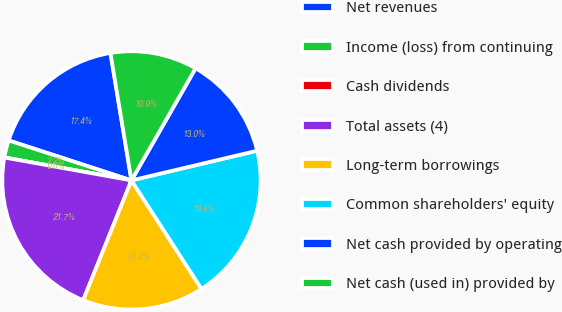<chart> <loc_0><loc_0><loc_500><loc_500><pie_chart><fcel>Net revenues<fcel>Income (loss) from continuing<fcel>Cash dividends<fcel>Total assets (4)<fcel>Long-term borrowings<fcel>Common shareholders' equity<fcel>Net cash provided by operating<fcel>Net cash (used in) provided by<nl><fcel>17.39%<fcel>2.17%<fcel>0.0%<fcel>21.74%<fcel>15.22%<fcel>19.57%<fcel>13.04%<fcel>10.87%<nl></chart> 